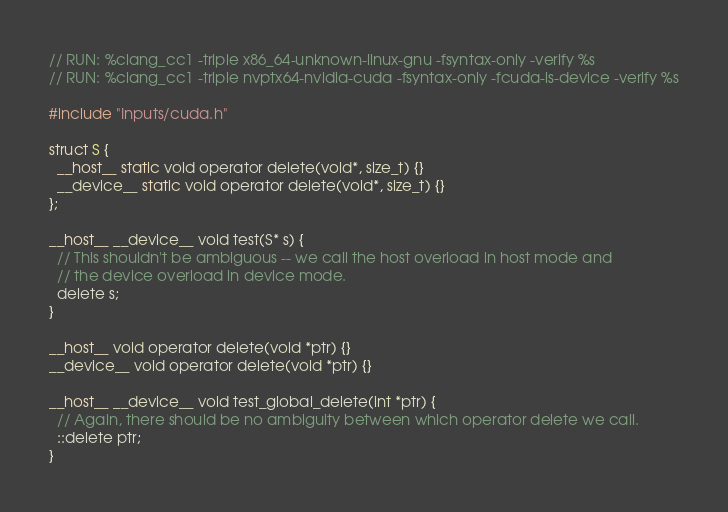Convert code to text. <code><loc_0><loc_0><loc_500><loc_500><_Cuda_>
// RUN: %clang_cc1 -triple x86_64-unknown-linux-gnu -fsyntax-only -verify %s
// RUN: %clang_cc1 -triple nvptx64-nvidia-cuda -fsyntax-only -fcuda-is-device -verify %s

#include "Inputs/cuda.h"

struct S {
  __host__ static void operator delete(void*, size_t) {}
  __device__ static void operator delete(void*, size_t) {}
};

__host__ __device__ void test(S* s) {
  // This shouldn't be ambiguous -- we call the host overload in host mode and
  // the device overload in device mode.
  delete s;
}

__host__ void operator delete(void *ptr) {}
__device__ void operator delete(void *ptr) {}

__host__ __device__ void test_global_delete(int *ptr) {
  // Again, there should be no ambiguity between which operator delete we call.
  ::delete ptr;
}
</code> 